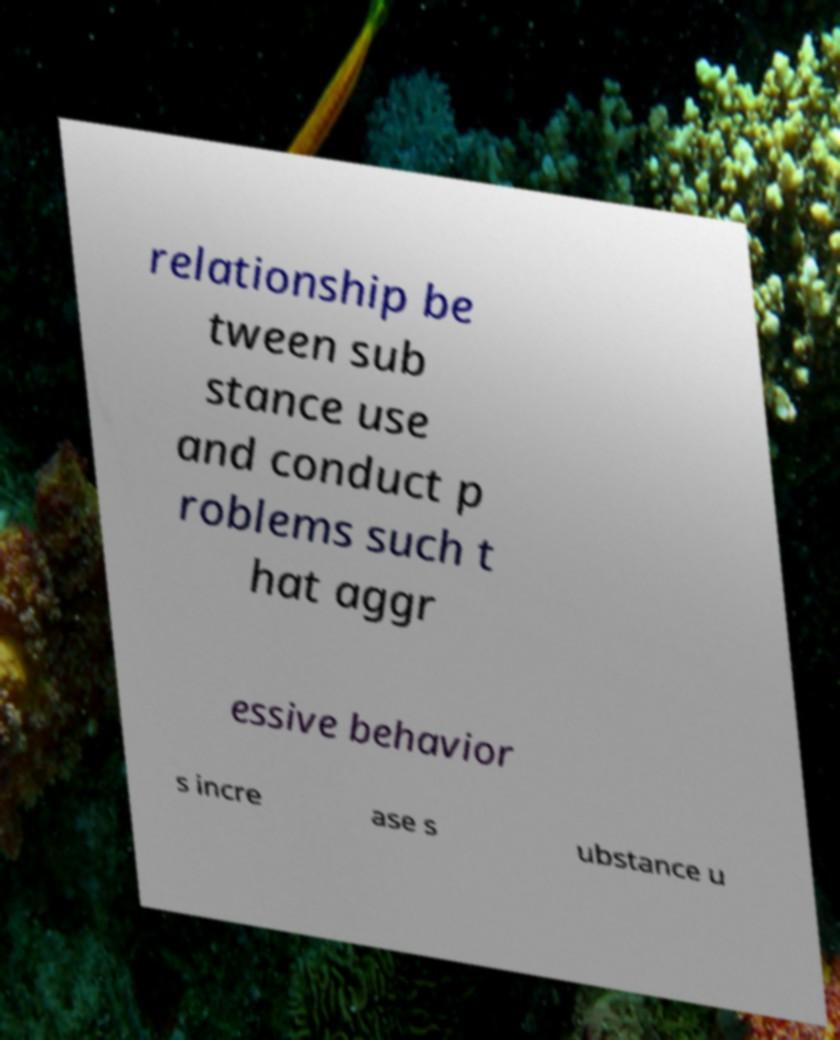I need the written content from this picture converted into text. Can you do that? relationship be tween sub stance use and conduct p roblems such t hat aggr essive behavior s incre ase s ubstance u 